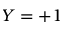<formula> <loc_0><loc_0><loc_500><loc_500>Y = + 1</formula> 